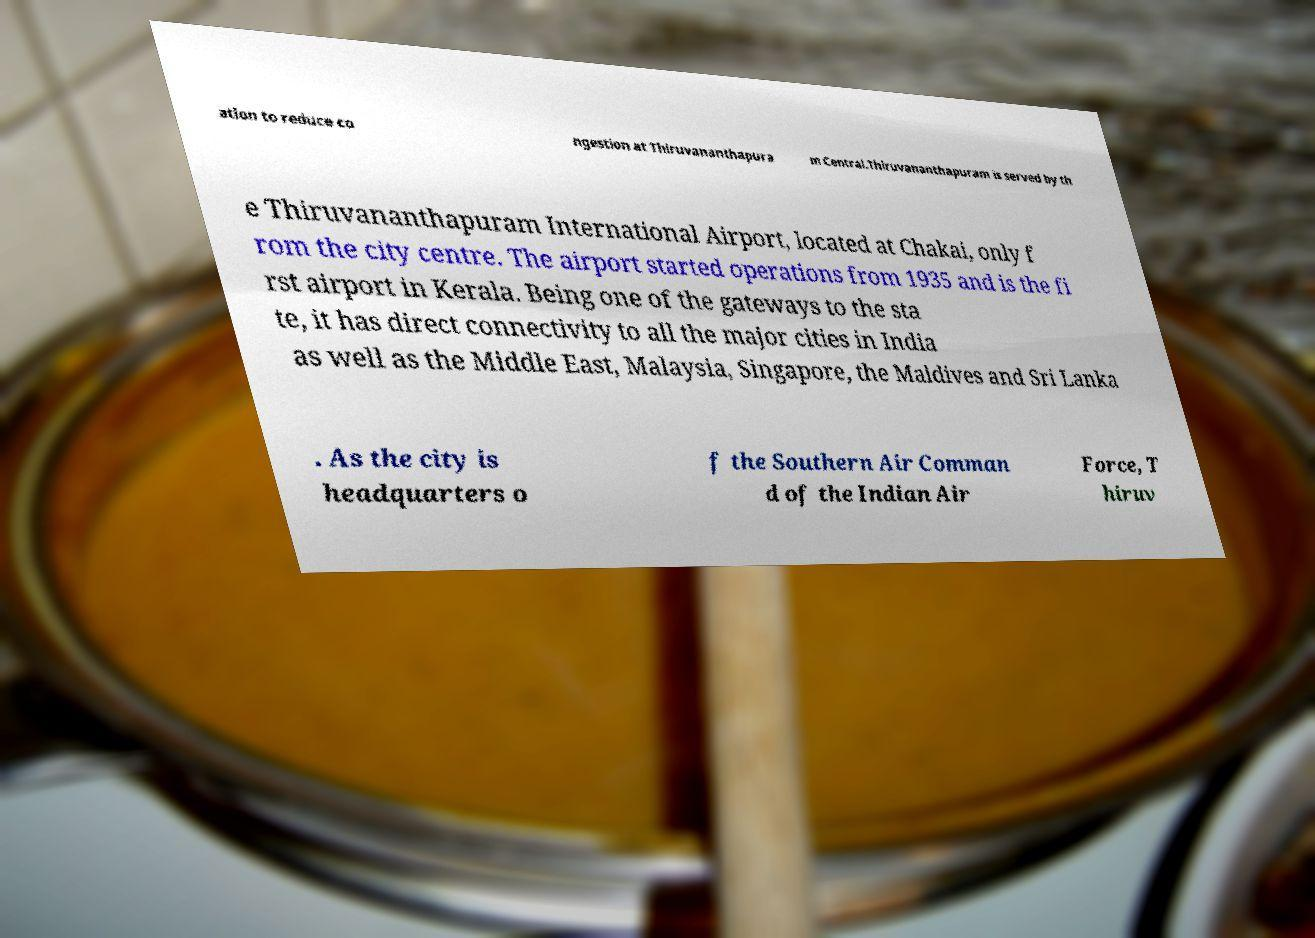Can you accurately transcribe the text from the provided image for me? ation to reduce co ngestion at Thiruvananthapura m Central.Thiruvananthapuram is served by th e Thiruvananthapuram International Airport, located at Chakai, only f rom the city centre. The airport started operations from 1935 and is the fi rst airport in Kerala. Being one of the gateways to the sta te, it has direct connectivity to all the major cities in India as well as the Middle East, Malaysia, Singapore, the Maldives and Sri Lanka . As the city is headquarters o f the Southern Air Comman d of the Indian Air Force, T hiruv 